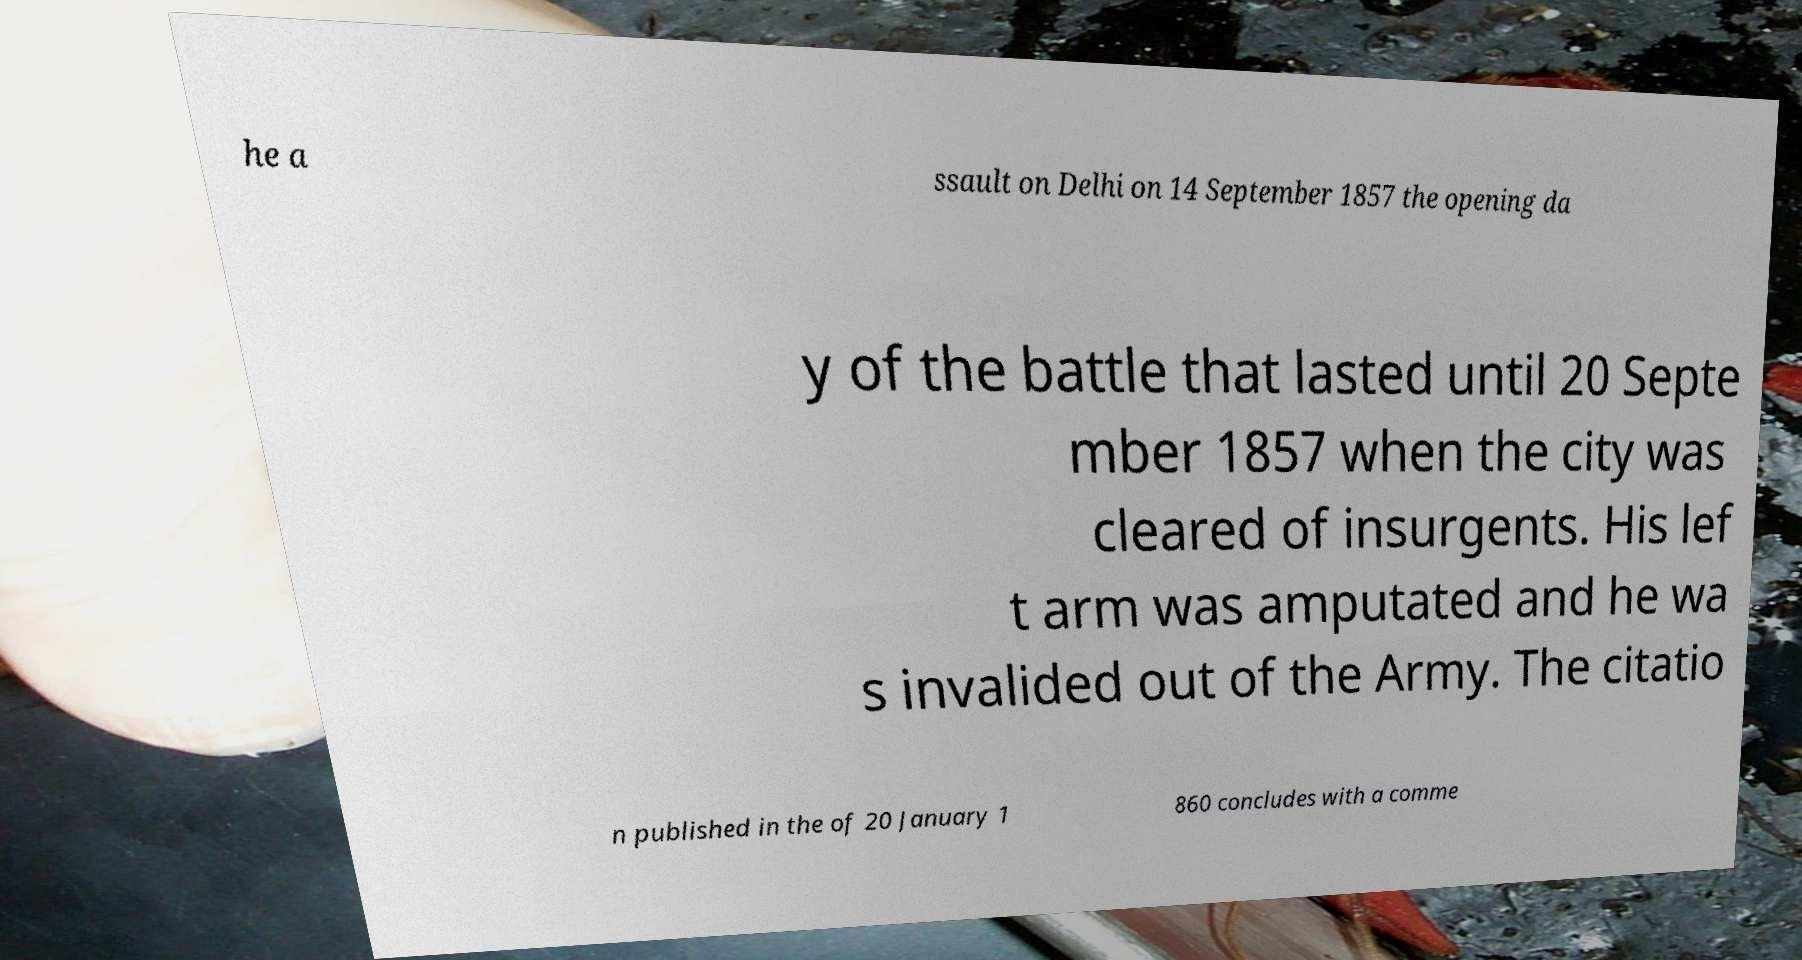There's text embedded in this image that I need extracted. Can you transcribe it verbatim? he a ssault on Delhi on 14 September 1857 the opening da y of the battle that lasted until 20 Septe mber 1857 when the city was cleared of insurgents. His lef t arm was amputated and he wa s invalided out of the Army. The citatio n published in the of 20 January 1 860 concludes with a comme 